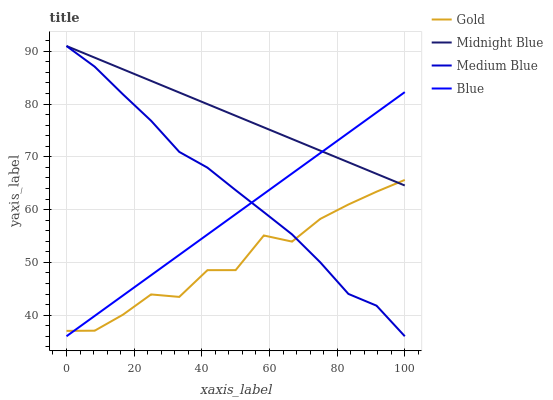Does Gold have the minimum area under the curve?
Answer yes or no. Yes. Does Midnight Blue have the maximum area under the curve?
Answer yes or no. Yes. Does Medium Blue have the minimum area under the curve?
Answer yes or no. No. Does Medium Blue have the maximum area under the curve?
Answer yes or no. No. Is Midnight Blue the smoothest?
Answer yes or no. Yes. Is Gold the roughest?
Answer yes or no. Yes. Is Medium Blue the smoothest?
Answer yes or no. No. Is Medium Blue the roughest?
Answer yes or no. No. Does Blue have the lowest value?
Answer yes or no. Yes. Does Midnight Blue have the lowest value?
Answer yes or no. No. Does Midnight Blue have the highest value?
Answer yes or no. Yes. Does Gold have the highest value?
Answer yes or no. No. Does Midnight Blue intersect Medium Blue?
Answer yes or no. Yes. Is Midnight Blue less than Medium Blue?
Answer yes or no. No. Is Midnight Blue greater than Medium Blue?
Answer yes or no. No. 